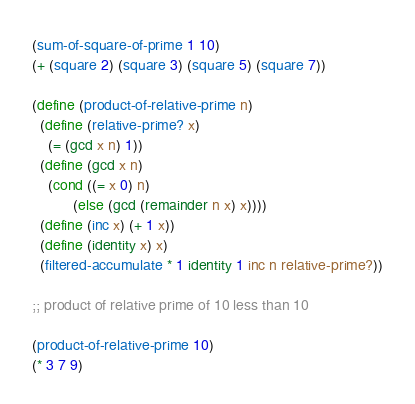<code> <loc_0><loc_0><loc_500><loc_500><_Scheme_>
(sum-of-square-of-prime 1 10)
(+ (square 2) (square 3) (square 5) (square 7))

(define (product-of-relative-prime n)
  (define (relative-prime? x)
    (= (gcd x n) 1))
  (define (gcd x n)
    (cond ((= x 0) n)
          (else (gcd (remainder n x) x))))
  (define (inc x) (+ 1 x))
  (define (identity x) x)
  (filtered-accumulate * 1 identity 1 inc n relative-prime?))

;; product of relative prime of 10 less than 10

(product-of-relative-prime 10)
(* 3 7 9)
</code> 